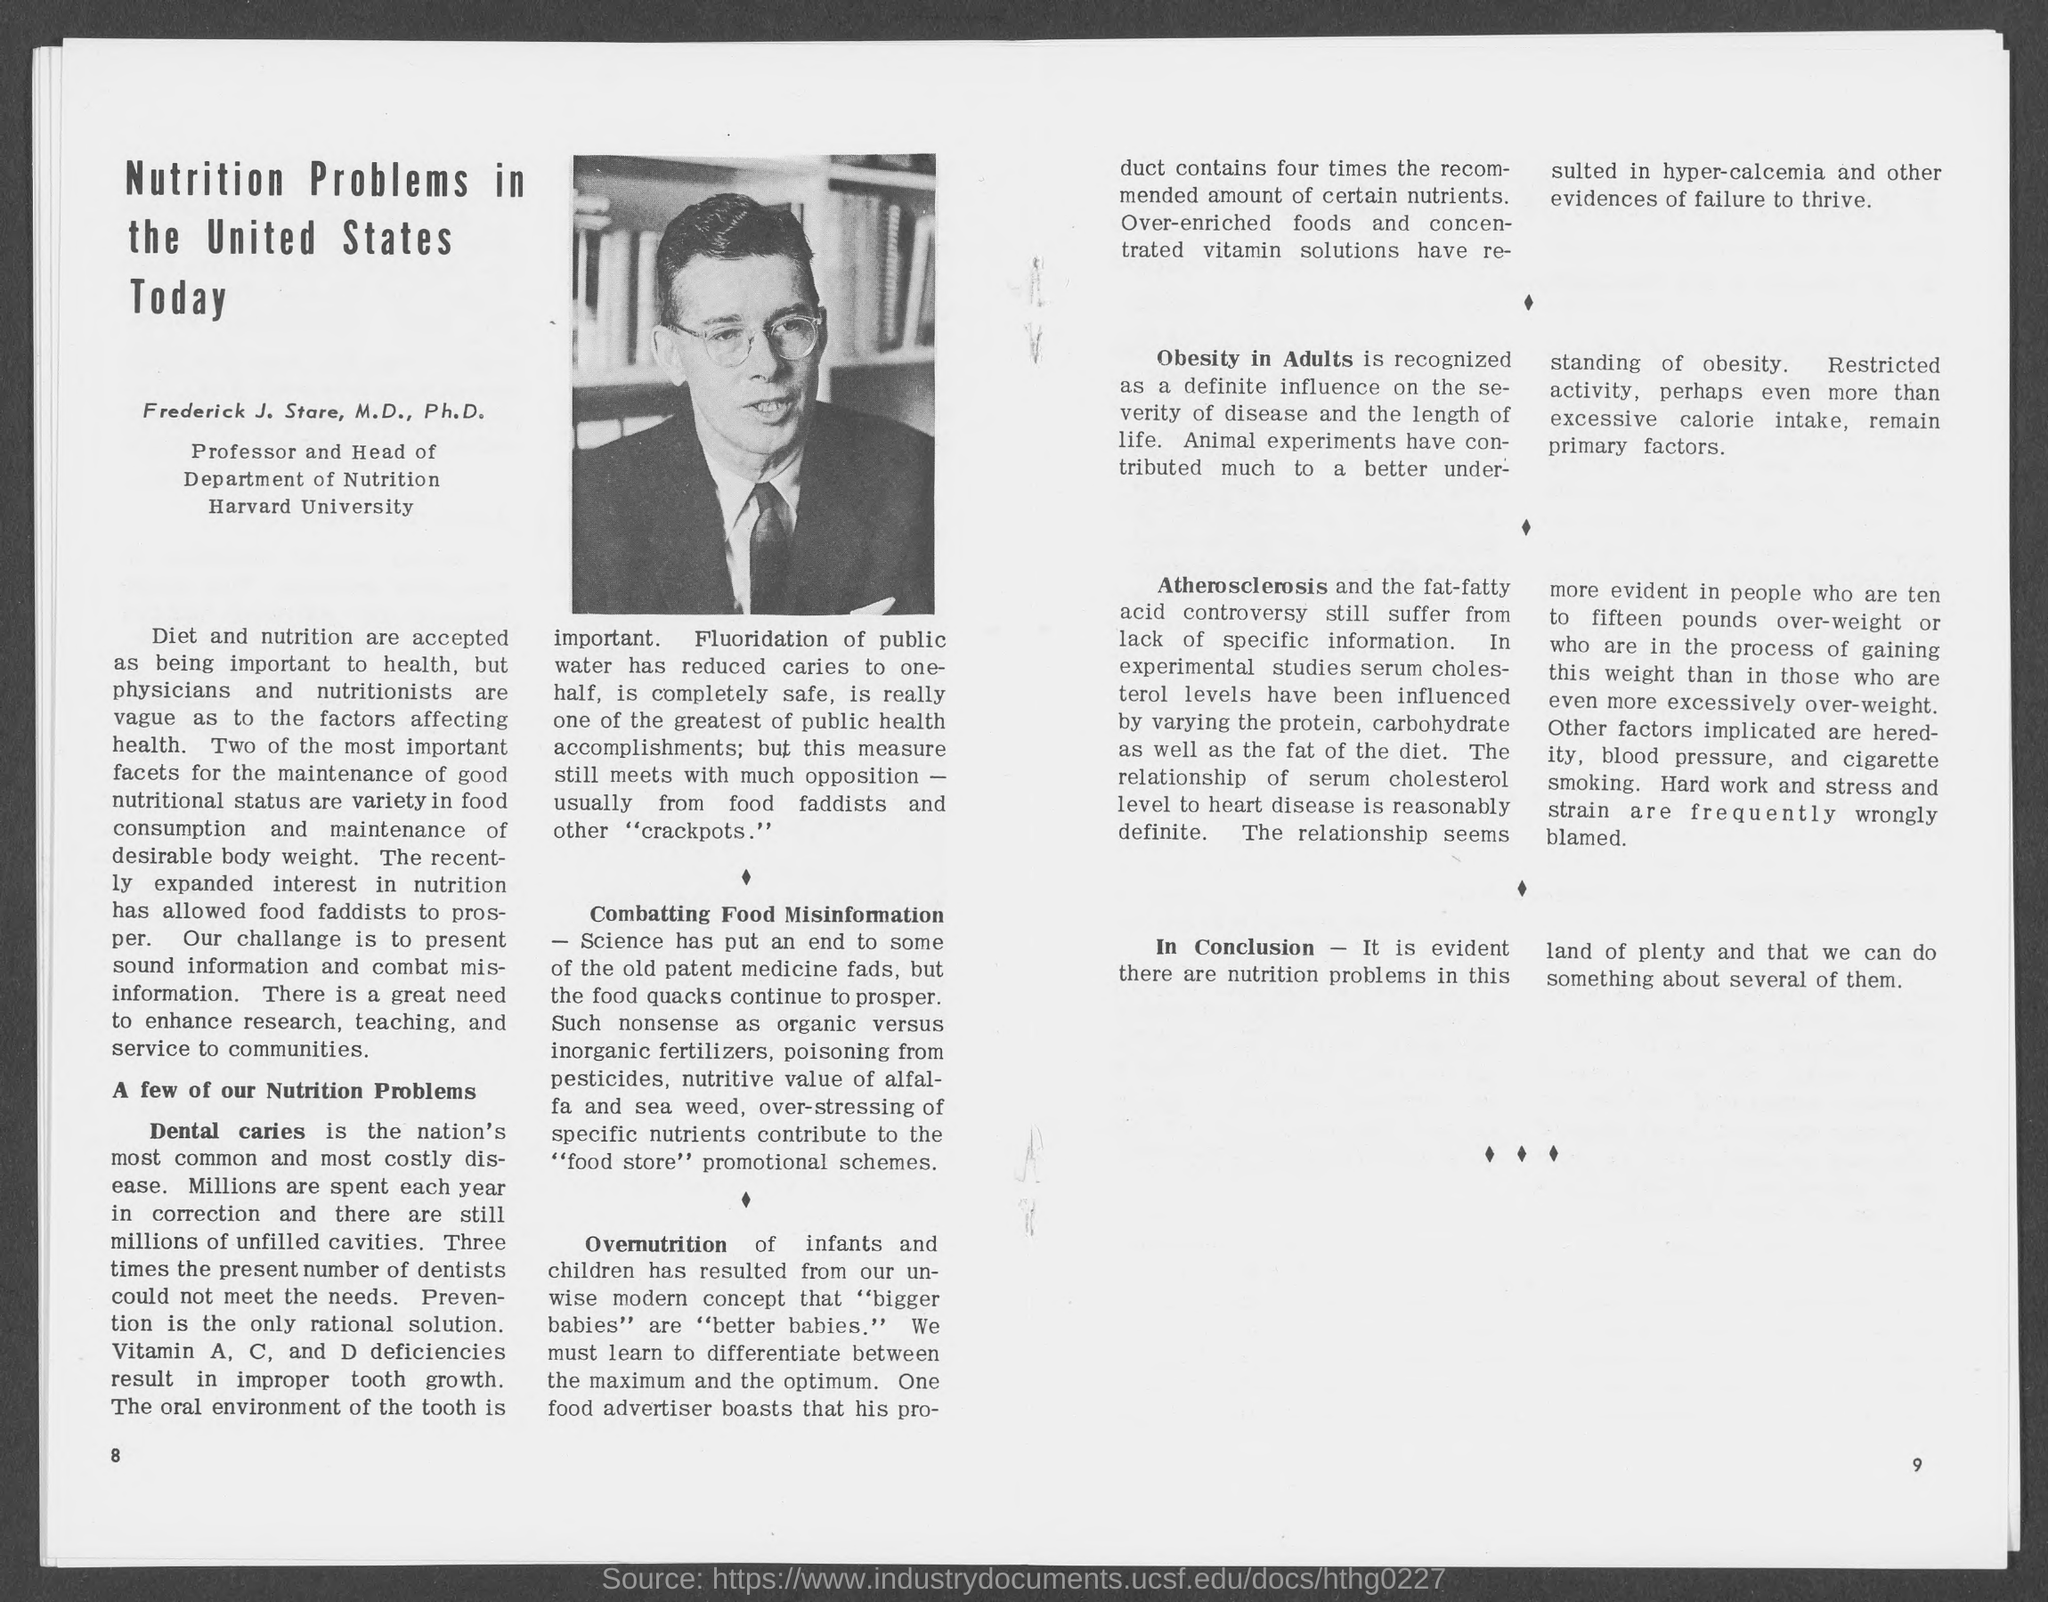What is the number at bottom left page ?
Offer a very short reply. 8. What is the number at bottom right page?
Make the answer very short. 9. 